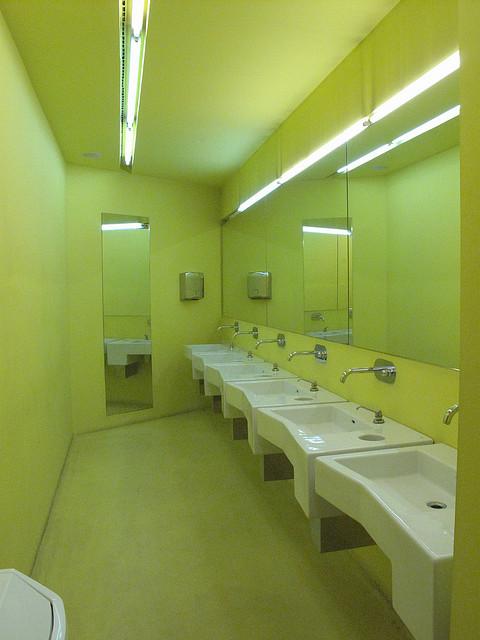How many sinks are in the bathroom?
Short answer required. 6. Are mirrors present?
Quick response, please. Yes. Is this a public restroom?
Give a very brief answer. Yes. Is there a TV?
Give a very brief answer. No. 